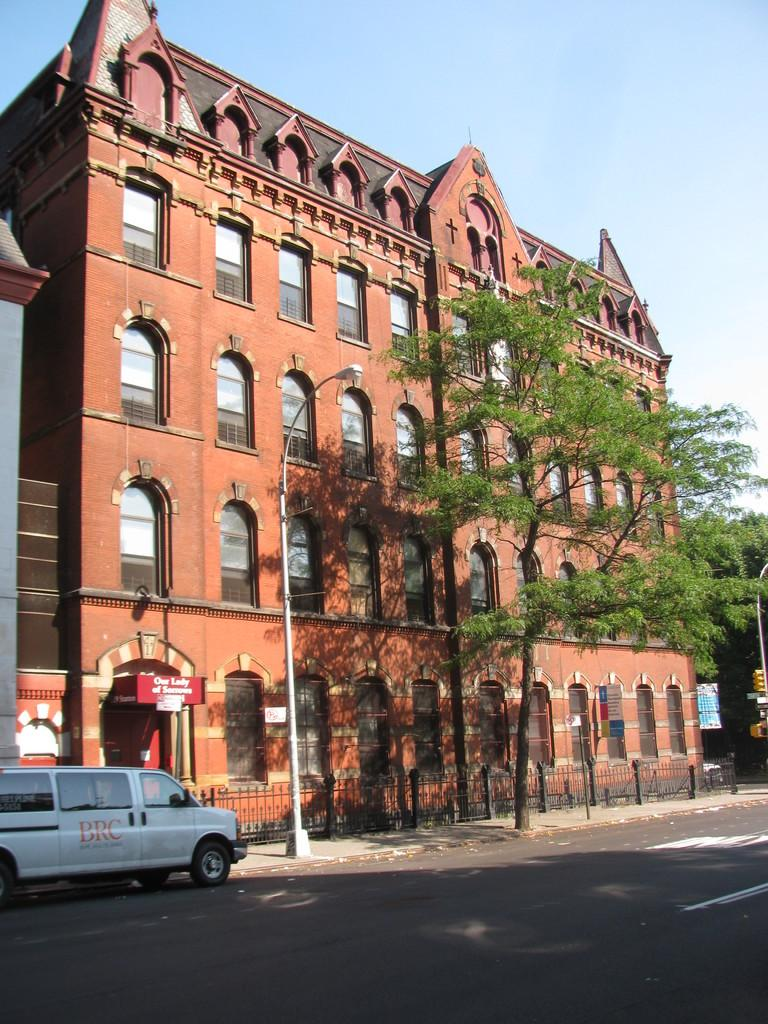What type of structure is present in the image? There is a building in the image. What natural element is also visible in the image? There is a tree in the image. What type of lighting is present along the road in the image? There are street lights in the image. What mode of transportation can be seen in the image? There is a vehicle in the image. What type of pathway is visible in the image? There is a road in the image. What type of barrier is present in the image? There is a fence in the image. What can be seen in the background of the image? The sky is visible in the background of the image. What type of lunch is being served in the image? There is no lunch present in the image; it features a building, a tree, street lights, a vehicle, a road, a fence, and the sky. How much money is visible in the image? There is no money present in the image. 